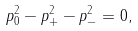Convert formula to latex. <formula><loc_0><loc_0><loc_500><loc_500>p _ { 0 } ^ { 2 } - p _ { + } ^ { 2 } - p _ { - } ^ { 2 } = 0 ,</formula> 